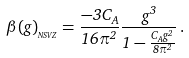<formula> <loc_0><loc_0><loc_500><loc_500>\beta ( g ) _ { _ { N S V Z } } = \frac { - 3 C _ { A } } { 1 6 \pi ^ { 2 } } \frac { g ^ { 3 } } { 1 - \frac { C _ { A } g ^ { 2 } } { 8 \pi ^ { 2 } } } \, .</formula> 